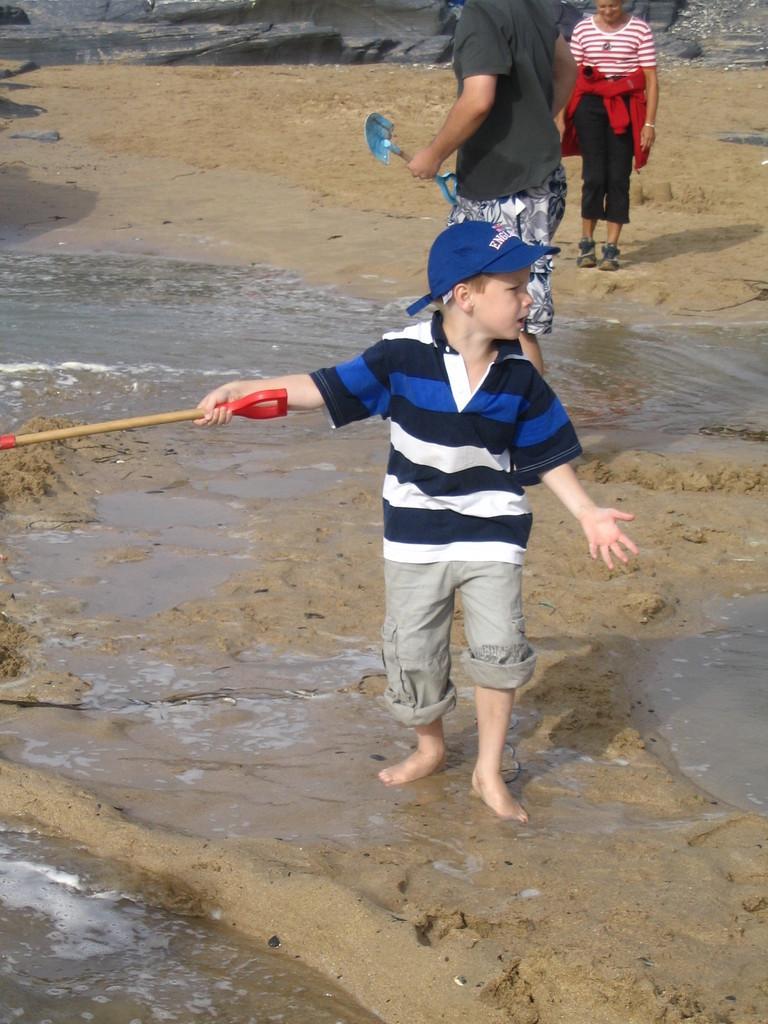Can you describe this image briefly? In this image, we can see people and some are holding objects. At the bottom, there is water and sand. 